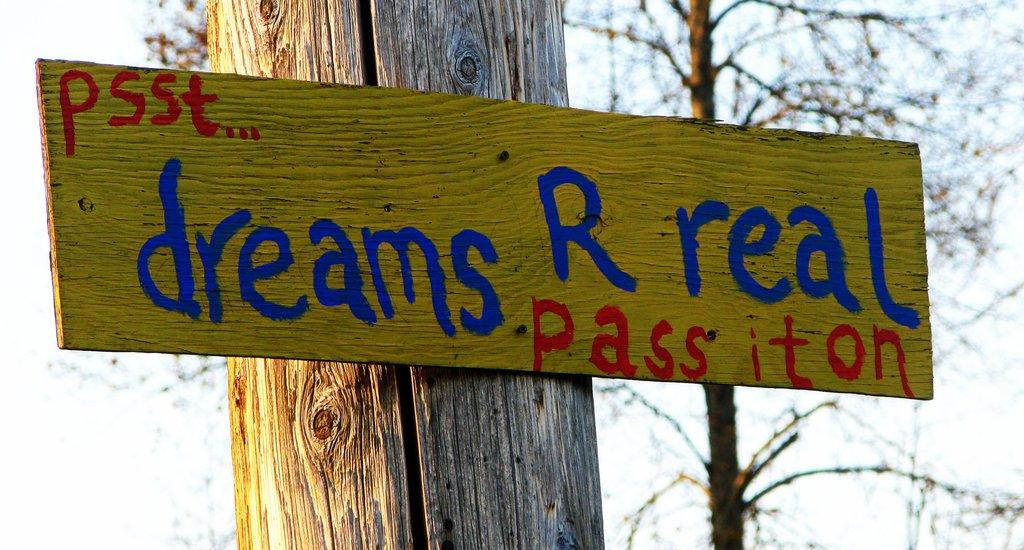What is attached to the tree trunk in the image? There is a board on a tree trunk in the image. What type of natural object is present in the image? There is a tree in the image. What color is the background of the image? The background of the image is white. How many credits are visible on the canvas in the image? There is no canvas or credits present in the image. What type of currency is shown on the tree in the image? There is no currency present in the image; it features a board on a tree trunk and a tree. 